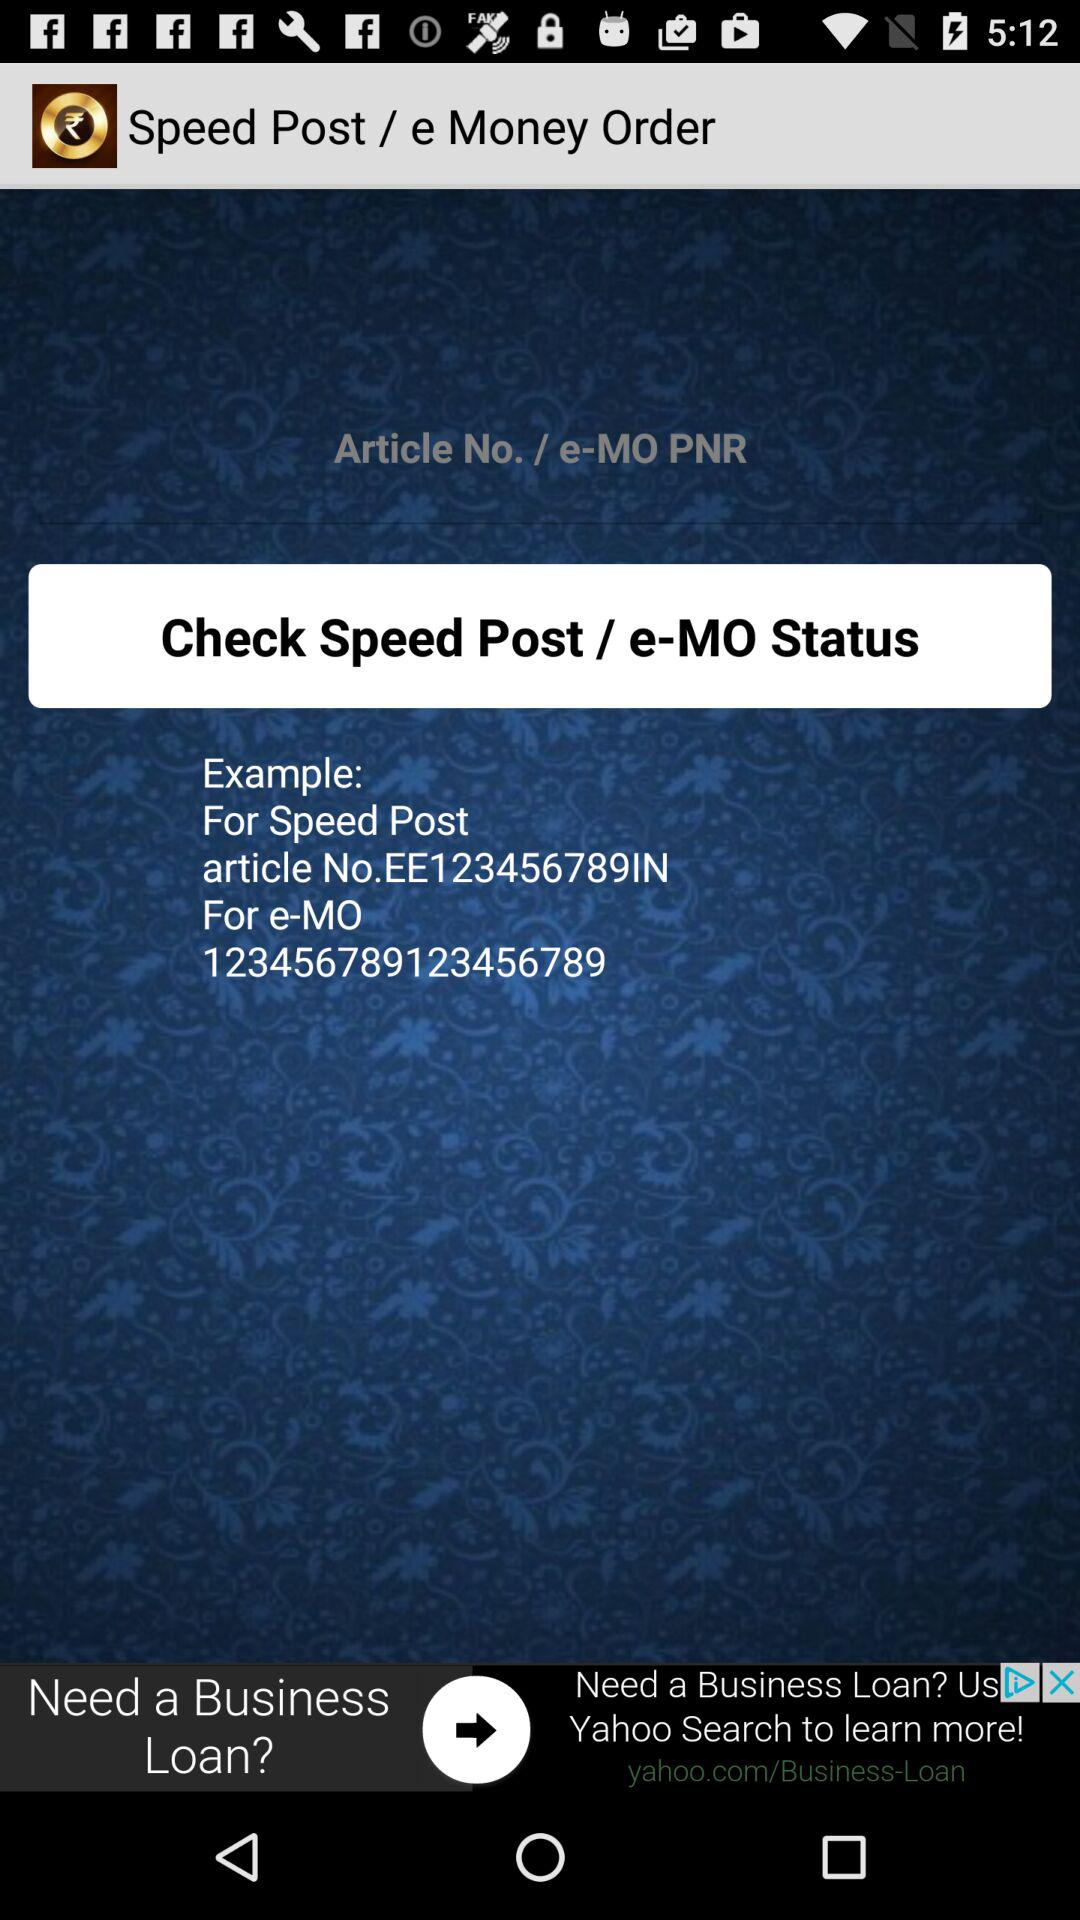What is the article number? The article number is EE123456789IN. 